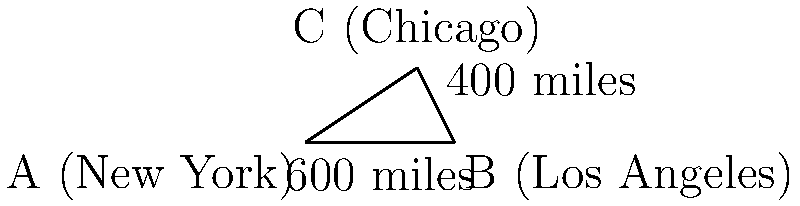As a seasoned traveler, you're planning a journey across the United States. On your map, New York (A) and Los Angeles (B) are connected by a straight line measuring 600 miles. Chicago (C) is located 400 miles north of Los Angeles, forming a right angle with the New York-Los Angeles line. Using the Pythagorean theorem, calculate the direct distance between New York and Chicago to the nearest mile. Let's approach this step-by-step:

1) We can treat this as a right-angled triangle problem, where:
   - The distance from New York to Los Angeles is the base (b)
   - The distance from Los Angeles to Chicago is the height (h)
   - The distance from New York to Chicago is the hypotenuse (c)

2) We know that:
   - $b = 600$ miles (New York to Los Angeles)
   - $h = 400$ miles (Los Angeles to Chicago)

3) The Pythagorean theorem states that in a right-angled triangle:

   $a^2 + b^2 = c^2$

   Where $c$ is the hypotenuse (the side we're trying to find).

4) Plugging in our known values:

   $600^2 + 400^2 = c^2$

5) Let's calculate:
   $360,000 + 160,000 = c^2$
   $520,000 = c^2$

6) To find $c$, we need to take the square root of both sides:

   $\sqrt{520,000} = c$

7) Using a calculator or computer:

   $c \approx 721.11$ miles

8) Rounding to the nearest mile:

   $c \approx 721$ miles

Therefore, the direct distance between New York and Chicago is approximately 721 miles.
Answer: 721 miles 